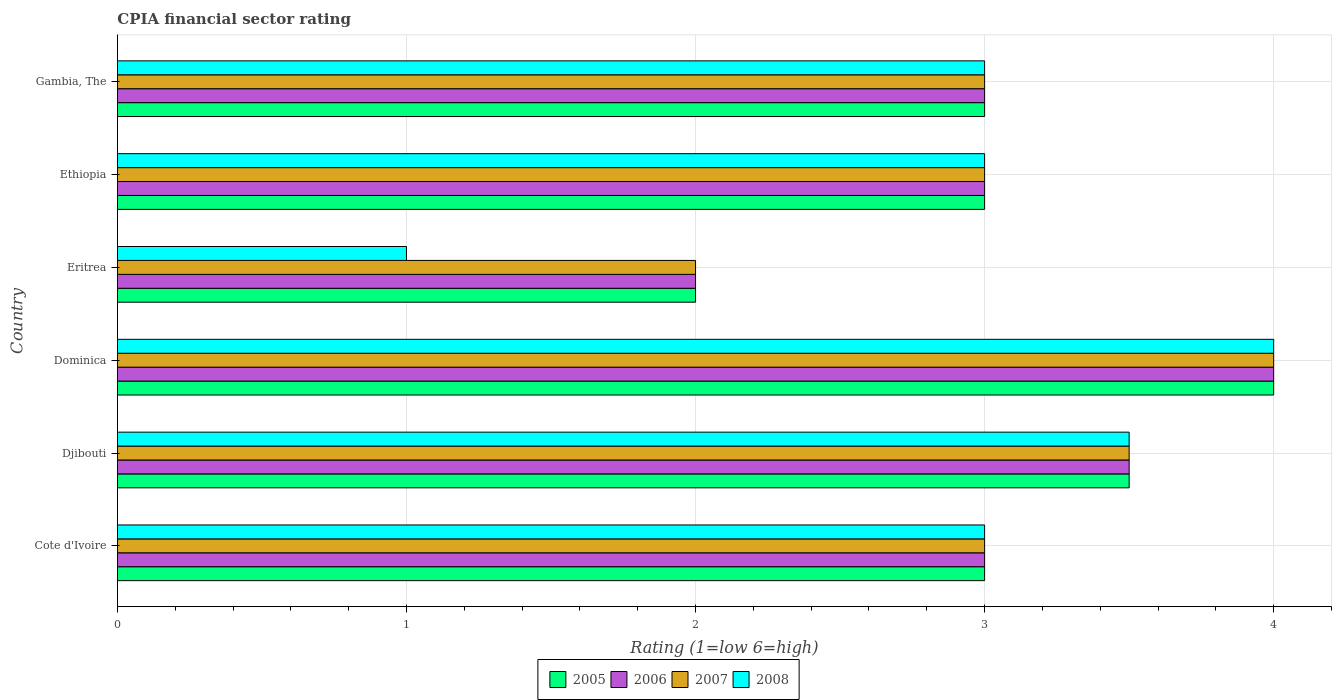Are the number of bars per tick equal to the number of legend labels?
Keep it short and to the point. Yes. Are the number of bars on each tick of the Y-axis equal?
Offer a very short reply. Yes. How many bars are there on the 6th tick from the top?
Ensure brevity in your answer.  4. What is the label of the 6th group of bars from the top?
Provide a succinct answer. Cote d'Ivoire. In which country was the CPIA rating in 2008 maximum?
Your answer should be very brief. Dominica. In which country was the CPIA rating in 2005 minimum?
Provide a short and direct response. Eritrea. What is the difference between the CPIA rating in 2006 in Cote d'Ivoire and the CPIA rating in 2008 in Djibouti?
Your response must be concise. -0.5. What is the average CPIA rating in 2006 per country?
Make the answer very short. 3.08. What is the difference between the CPIA rating in 2008 and CPIA rating in 2005 in Cote d'Ivoire?
Your response must be concise. 0. Is the CPIA rating in 2006 in Djibouti less than that in Dominica?
Make the answer very short. Yes. What is the difference between the highest and the second highest CPIA rating in 2006?
Provide a short and direct response. 0.5. Is it the case that in every country, the sum of the CPIA rating in 2008 and CPIA rating in 2007 is greater than the sum of CPIA rating in 2006 and CPIA rating in 2005?
Provide a succinct answer. No. What does the 3rd bar from the bottom in Djibouti represents?
Provide a short and direct response. 2007. How many bars are there?
Ensure brevity in your answer.  24. Are all the bars in the graph horizontal?
Keep it short and to the point. Yes. What is the difference between two consecutive major ticks on the X-axis?
Your response must be concise. 1. Are the values on the major ticks of X-axis written in scientific E-notation?
Provide a succinct answer. No. Does the graph contain any zero values?
Make the answer very short. No. Does the graph contain grids?
Offer a very short reply. Yes. Where does the legend appear in the graph?
Keep it short and to the point. Bottom center. How are the legend labels stacked?
Provide a succinct answer. Horizontal. What is the title of the graph?
Offer a very short reply. CPIA financial sector rating. Does "1999" appear as one of the legend labels in the graph?
Your answer should be compact. No. What is the label or title of the X-axis?
Your response must be concise. Rating (1=low 6=high). What is the label or title of the Y-axis?
Your answer should be compact. Country. What is the Rating (1=low 6=high) in 2005 in Djibouti?
Give a very brief answer. 3.5. What is the Rating (1=low 6=high) in 2007 in Djibouti?
Your answer should be very brief. 3.5. What is the Rating (1=low 6=high) in 2008 in Djibouti?
Give a very brief answer. 3.5. What is the Rating (1=low 6=high) of 2005 in Dominica?
Your answer should be compact. 4. What is the Rating (1=low 6=high) of 2005 in Eritrea?
Give a very brief answer. 2. What is the Rating (1=low 6=high) in 2006 in Eritrea?
Your answer should be compact. 2. What is the Rating (1=low 6=high) of 2005 in Ethiopia?
Offer a very short reply. 3. What is the Rating (1=low 6=high) of 2005 in Gambia, The?
Keep it short and to the point. 3. What is the Rating (1=low 6=high) in 2006 in Gambia, The?
Your answer should be very brief. 3. What is the Rating (1=low 6=high) of 2008 in Gambia, The?
Provide a succinct answer. 3. Across all countries, what is the maximum Rating (1=low 6=high) in 2005?
Your response must be concise. 4. Across all countries, what is the maximum Rating (1=low 6=high) of 2006?
Provide a succinct answer. 4. Across all countries, what is the minimum Rating (1=low 6=high) of 2005?
Provide a succinct answer. 2. What is the difference between the Rating (1=low 6=high) of 2005 in Cote d'Ivoire and that in Djibouti?
Give a very brief answer. -0.5. What is the difference between the Rating (1=low 6=high) in 2006 in Cote d'Ivoire and that in Djibouti?
Offer a terse response. -0.5. What is the difference between the Rating (1=low 6=high) in 2008 in Cote d'Ivoire and that in Djibouti?
Your answer should be compact. -0.5. What is the difference between the Rating (1=low 6=high) in 2005 in Cote d'Ivoire and that in Dominica?
Offer a terse response. -1. What is the difference between the Rating (1=low 6=high) in 2006 in Cote d'Ivoire and that in Dominica?
Your answer should be very brief. -1. What is the difference between the Rating (1=low 6=high) in 2006 in Cote d'Ivoire and that in Eritrea?
Your response must be concise. 1. What is the difference between the Rating (1=low 6=high) in 2006 in Cote d'Ivoire and that in Ethiopia?
Offer a terse response. 0. What is the difference between the Rating (1=low 6=high) of 2007 in Cote d'Ivoire and that in Ethiopia?
Offer a terse response. 0. What is the difference between the Rating (1=low 6=high) in 2008 in Cote d'Ivoire and that in Ethiopia?
Provide a succinct answer. 0. What is the difference between the Rating (1=low 6=high) in 2007 in Cote d'Ivoire and that in Gambia, The?
Your answer should be very brief. 0. What is the difference between the Rating (1=low 6=high) of 2006 in Djibouti and that in Dominica?
Make the answer very short. -0.5. What is the difference between the Rating (1=low 6=high) in 2008 in Djibouti and that in Dominica?
Your response must be concise. -0.5. What is the difference between the Rating (1=low 6=high) in 2006 in Djibouti and that in Eritrea?
Give a very brief answer. 1.5. What is the difference between the Rating (1=low 6=high) of 2008 in Djibouti and that in Eritrea?
Your response must be concise. 2.5. What is the difference between the Rating (1=low 6=high) in 2008 in Djibouti and that in Ethiopia?
Provide a short and direct response. 0.5. What is the difference between the Rating (1=low 6=high) of 2005 in Djibouti and that in Gambia, The?
Keep it short and to the point. 0.5. What is the difference between the Rating (1=low 6=high) of 2007 in Djibouti and that in Gambia, The?
Your response must be concise. 0.5. What is the difference between the Rating (1=low 6=high) in 2008 in Djibouti and that in Gambia, The?
Offer a terse response. 0.5. What is the difference between the Rating (1=low 6=high) of 2005 in Dominica and that in Eritrea?
Provide a succinct answer. 2. What is the difference between the Rating (1=low 6=high) of 2006 in Dominica and that in Eritrea?
Ensure brevity in your answer.  2. What is the difference between the Rating (1=low 6=high) of 2007 in Dominica and that in Eritrea?
Keep it short and to the point. 2. What is the difference between the Rating (1=low 6=high) in 2006 in Dominica and that in Ethiopia?
Keep it short and to the point. 1. What is the difference between the Rating (1=low 6=high) in 2007 in Dominica and that in Ethiopia?
Offer a terse response. 1. What is the difference between the Rating (1=low 6=high) of 2008 in Dominica and that in Ethiopia?
Your answer should be very brief. 1. What is the difference between the Rating (1=low 6=high) in 2007 in Dominica and that in Gambia, The?
Ensure brevity in your answer.  1. What is the difference between the Rating (1=low 6=high) in 2008 in Eritrea and that in Ethiopia?
Offer a terse response. -2. What is the difference between the Rating (1=low 6=high) of 2005 in Eritrea and that in Gambia, The?
Your response must be concise. -1. What is the difference between the Rating (1=low 6=high) of 2006 in Eritrea and that in Gambia, The?
Ensure brevity in your answer.  -1. What is the difference between the Rating (1=low 6=high) of 2007 in Eritrea and that in Gambia, The?
Your answer should be compact. -1. What is the difference between the Rating (1=low 6=high) in 2007 in Ethiopia and that in Gambia, The?
Your answer should be compact. 0. What is the difference between the Rating (1=low 6=high) in 2008 in Ethiopia and that in Gambia, The?
Keep it short and to the point. 0. What is the difference between the Rating (1=low 6=high) in 2005 in Cote d'Ivoire and the Rating (1=low 6=high) in 2006 in Djibouti?
Ensure brevity in your answer.  -0.5. What is the difference between the Rating (1=low 6=high) of 2005 in Cote d'Ivoire and the Rating (1=low 6=high) of 2007 in Djibouti?
Make the answer very short. -0.5. What is the difference between the Rating (1=low 6=high) of 2005 in Cote d'Ivoire and the Rating (1=low 6=high) of 2008 in Djibouti?
Ensure brevity in your answer.  -0.5. What is the difference between the Rating (1=low 6=high) of 2007 in Cote d'Ivoire and the Rating (1=low 6=high) of 2008 in Dominica?
Make the answer very short. -1. What is the difference between the Rating (1=low 6=high) of 2005 in Cote d'Ivoire and the Rating (1=low 6=high) of 2007 in Eritrea?
Provide a succinct answer. 1. What is the difference between the Rating (1=low 6=high) in 2005 in Cote d'Ivoire and the Rating (1=low 6=high) in 2008 in Eritrea?
Your answer should be compact. 2. What is the difference between the Rating (1=low 6=high) of 2006 in Cote d'Ivoire and the Rating (1=low 6=high) of 2007 in Eritrea?
Ensure brevity in your answer.  1. What is the difference between the Rating (1=low 6=high) of 2007 in Cote d'Ivoire and the Rating (1=low 6=high) of 2008 in Eritrea?
Provide a short and direct response. 2. What is the difference between the Rating (1=low 6=high) in 2005 in Cote d'Ivoire and the Rating (1=low 6=high) in 2006 in Ethiopia?
Your answer should be very brief. 0. What is the difference between the Rating (1=low 6=high) in 2005 in Cote d'Ivoire and the Rating (1=low 6=high) in 2008 in Ethiopia?
Give a very brief answer. 0. What is the difference between the Rating (1=low 6=high) of 2006 in Cote d'Ivoire and the Rating (1=low 6=high) of 2007 in Ethiopia?
Provide a short and direct response. 0. What is the difference between the Rating (1=low 6=high) of 2006 in Cote d'Ivoire and the Rating (1=low 6=high) of 2008 in Ethiopia?
Make the answer very short. 0. What is the difference between the Rating (1=low 6=high) of 2005 in Cote d'Ivoire and the Rating (1=low 6=high) of 2006 in Gambia, The?
Your answer should be compact. 0. What is the difference between the Rating (1=low 6=high) in 2005 in Cote d'Ivoire and the Rating (1=low 6=high) in 2007 in Gambia, The?
Give a very brief answer. 0. What is the difference between the Rating (1=low 6=high) of 2005 in Cote d'Ivoire and the Rating (1=low 6=high) of 2008 in Gambia, The?
Provide a succinct answer. 0. What is the difference between the Rating (1=low 6=high) in 2006 in Cote d'Ivoire and the Rating (1=low 6=high) in 2007 in Gambia, The?
Provide a succinct answer. 0. What is the difference between the Rating (1=low 6=high) of 2005 in Djibouti and the Rating (1=low 6=high) of 2006 in Dominica?
Offer a terse response. -0.5. What is the difference between the Rating (1=low 6=high) of 2005 in Djibouti and the Rating (1=low 6=high) of 2007 in Dominica?
Your answer should be very brief. -0.5. What is the difference between the Rating (1=low 6=high) in 2006 in Djibouti and the Rating (1=low 6=high) in 2007 in Dominica?
Your response must be concise. -0.5. What is the difference between the Rating (1=low 6=high) in 2007 in Djibouti and the Rating (1=low 6=high) in 2008 in Dominica?
Keep it short and to the point. -0.5. What is the difference between the Rating (1=low 6=high) of 2005 in Djibouti and the Rating (1=low 6=high) of 2006 in Eritrea?
Make the answer very short. 1.5. What is the difference between the Rating (1=low 6=high) of 2005 in Djibouti and the Rating (1=low 6=high) of 2007 in Eritrea?
Provide a short and direct response. 1.5. What is the difference between the Rating (1=low 6=high) in 2005 in Djibouti and the Rating (1=low 6=high) in 2008 in Eritrea?
Offer a very short reply. 2.5. What is the difference between the Rating (1=low 6=high) in 2006 in Djibouti and the Rating (1=low 6=high) in 2007 in Eritrea?
Ensure brevity in your answer.  1.5. What is the difference between the Rating (1=low 6=high) of 2006 in Djibouti and the Rating (1=low 6=high) of 2007 in Ethiopia?
Provide a short and direct response. 0.5. What is the difference between the Rating (1=low 6=high) of 2007 in Djibouti and the Rating (1=low 6=high) of 2008 in Ethiopia?
Offer a very short reply. 0.5. What is the difference between the Rating (1=low 6=high) of 2005 in Djibouti and the Rating (1=low 6=high) of 2007 in Gambia, The?
Your response must be concise. 0.5. What is the difference between the Rating (1=low 6=high) in 2005 in Djibouti and the Rating (1=low 6=high) in 2008 in Gambia, The?
Offer a terse response. 0.5. What is the difference between the Rating (1=low 6=high) in 2006 in Djibouti and the Rating (1=low 6=high) in 2007 in Gambia, The?
Offer a terse response. 0.5. What is the difference between the Rating (1=low 6=high) in 2005 in Dominica and the Rating (1=low 6=high) in 2006 in Eritrea?
Provide a short and direct response. 2. What is the difference between the Rating (1=low 6=high) of 2005 in Dominica and the Rating (1=low 6=high) of 2008 in Eritrea?
Offer a terse response. 3. What is the difference between the Rating (1=low 6=high) of 2006 in Dominica and the Rating (1=low 6=high) of 2007 in Eritrea?
Your answer should be very brief. 2. What is the difference between the Rating (1=low 6=high) of 2006 in Dominica and the Rating (1=low 6=high) of 2008 in Eritrea?
Provide a short and direct response. 3. What is the difference between the Rating (1=low 6=high) of 2005 in Dominica and the Rating (1=low 6=high) of 2008 in Ethiopia?
Provide a succinct answer. 1. What is the difference between the Rating (1=low 6=high) of 2006 in Dominica and the Rating (1=low 6=high) of 2007 in Ethiopia?
Offer a terse response. 1. What is the difference between the Rating (1=low 6=high) of 2006 in Dominica and the Rating (1=low 6=high) of 2008 in Ethiopia?
Your answer should be very brief. 1. What is the difference between the Rating (1=low 6=high) in 2005 in Dominica and the Rating (1=low 6=high) in 2006 in Gambia, The?
Offer a very short reply. 1. What is the difference between the Rating (1=low 6=high) of 2005 in Dominica and the Rating (1=low 6=high) of 2007 in Gambia, The?
Provide a succinct answer. 1. What is the difference between the Rating (1=low 6=high) of 2005 in Eritrea and the Rating (1=low 6=high) of 2008 in Ethiopia?
Give a very brief answer. -1. What is the difference between the Rating (1=low 6=high) in 2007 in Eritrea and the Rating (1=low 6=high) in 2008 in Ethiopia?
Give a very brief answer. -1. What is the difference between the Rating (1=low 6=high) in 2005 in Eritrea and the Rating (1=low 6=high) in 2006 in Gambia, The?
Make the answer very short. -1. What is the difference between the Rating (1=low 6=high) of 2005 in Eritrea and the Rating (1=low 6=high) of 2007 in Gambia, The?
Offer a terse response. -1. What is the difference between the Rating (1=low 6=high) of 2005 in Eritrea and the Rating (1=low 6=high) of 2008 in Gambia, The?
Keep it short and to the point. -1. What is the difference between the Rating (1=low 6=high) of 2006 in Eritrea and the Rating (1=low 6=high) of 2008 in Gambia, The?
Your response must be concise. -1. What is the difference between the Rating (1=low 6=high) in 2005 in Ethiopia and the Rating (1=low 6=high) in 2008 in Gambia, The?
Give a very brief answer. 0. What is the difference between the Rating (1=low 6=high) in 2006 in Ethiopia and the Rating (1=low 6=high) in 2007 in Gambia, The?
Make the answer very short. 0. What is the difference between the Rating (1=low 6=high) in 2006 in Ethiopia and the Rating (1=low 6=high) in 2008 in Gambia, The?
Your answer should be compact. 0. What is the difference between the Rating (1=low 6=high) of 2007 in Ethiopia and the Rating (1=low 6=high) of 2008 in Gambia, The?
Your answer should be compact. 0. What is the average Rating (1=low 6=high) of 2005 per country?
Your response must be concise. 3.08. What is the average Rating (1=low 6=high) of 2006 per country?
Your response must be concise. 3.08. What is the average Rating (1=low 6=high) of 2007 per country?
Make the answer very short. 3.08. What is the average Rating (1=low 6=high) of 2008 per country?
Give a very brief answer. 2.92. What is the difference between the Rating (1=low 6=high) of 2005 and Rating (1=low 6=high) of 2006 in Cote d'Ivoire?
Your answer should be compact. 0. What is the difference between the Rating (1=low 6=high) in 2005 and Rating (1=low 6=high) in 2007 in Cote d'Ivoire?
Your answer should be very brief. 0. What is the difference between the Rating (1=low 6=high) of 2006 and Rating (1=low 6=high) of 2007 in Cote d'Ivoire?
Your response must be concise. 0. What is the difference between the Rating (1=low 6=high) in 2006 and Rating (1=low 6=high) in 2008 in Cote d'Ivoire?
Your answer should be very brief. 0. What is the difference between the Rating (1=low 6=high) of 2007 and Rating (1=low 6=high) of 2008 in Cote d'Ivoire?
Your answer should be very brief. 0. What is the difference between the Rating (1=low 6=high) of 2005 and Rating (1=low 6=high) of 2007 in Djibouti?
Give a very brief answer. 0. What is the difference between the Rating (1=low 6=high) in 2005 and Rating (1=low 6=high) in 2008 in Djibouti?
Your answer should be compact. 0. What is the difference between the Rating (1=low 6=high) of 2005 and Rating (1=low 6=high) of 2008 in Dominica?
Ensure brevity in your answer.  0. What is the difference between the Rating (1=low 6=high) in 2006 and Rating (1=low 6=high) in 2008 in Dominica?
Make the answer very short. 0. What is the difference between the Rating (1=low 6=high) in 2007 and Rating (1=low 6=high) in 2008 in Dominica?
Your answer should be compact. 0. What is the difference between the Rating (1=low 6=high) of 2005 and Rating (1=low 6=high) of 2006 in Eritrea?
Your answer should be compact. 0. What is the difference between the Rating (1=low 6=high) in 2006 and Rating (1=low 6=high) in 2007 in Eritrea?
Provide a succinct answer. 0. What is the difference between the Rating (1=low 6=high) of 2006 and Rating (1=low 6=high) of 2007 in Ethiopia?
Provide a succinct answer. 0. What is the difference between the Rating (1=low 6=high) of 2006 and Rating (1=low 6=high) of 2008 in Ethiopia?
Your answer should be compact. 0. What is the difference between the Rating (1=low 6=high) of 2005 and Rating (1=low 6=high) of 2007 in Gambia, The?
Ensure brevity in your answer.  0. What is the difference between the Rating (1=low 6=high) in 2005 and Rating (1=low 6=high) in 2008 in Gambia, The?
Provide a short and direct response. 0. What is the difference between the Rating (1=low 6=high) of 2007 and Rating (1=low 6=high) of 2008 in Gambia, The?
Your response must be concise. 0. What is the ratio of the Rating (1=low 6=high) of 2005 in Cote d'Ivoire to that in Djibouti?
Your answer should be compact. 0.86. What is the ratio of the Rating (1=low 6=high) of 2008 in Cote d'Ivoire to that in Djibouti?
Offer a terse response. 0.86. What is the ratio of the Rating (1=low 6=high) in 2005 in Cote d'Ivoire to that in Dominica?
Ensure brevity in your answer.  0.75. What is the ratio of the Rating (1=low 6=high) in 2008 in Cote d'Ivoire to that in Dominica?
Keep it short and to the point. 0.75. What is the ratio of the Rating (1=low 6=high) in 2007 in Cote d'Ivoire to that in Eritrea?
Ensure brevity in your answer.  1.5. What is the ratio of the Rating (1=low 6=high) of 2008 in Cote d'Ivoire to that in Eritrea?
Your response must be concise. 3. What is the ratio of the Rating (1=low 6=high) of 2006 in Cote d'Ivoire to that in Ethiopia?
Give a very brief answer. 1. What is the ratio of the Rating (1=low 6=high) in 2008 in Cote d'Ivoire to that in Ethiopia?
Your answer should be compact. 1. What is the ratio of the Rating (1=low 6=high) of 2007 in Cote d'Ivoire to that in Gambia, The?
Your answer should be very brief. 1. What is the ratio of the Rating (1=low 6=high) in 2008 in Cote d'Ivoire to that in Gambia, The?
Your answer should be compact. 1. What is the ratio of the Rating (1=low 6=high) of 2006 in Djibouti to that in Dominica?
Keep it short and to the point. 0.88. What is the ratio of the Rating (1=low 6=high) of 2006 in Djibouti to that in Eritrea?
Keep it short and to the point. 1.75. What is the ratio of the Rating (1=low 6=high) in 2007 in Djibouti to that in Eritrea?
Provide a short and direct response. 1.75. What is the ratio of the Rating (1=low 6=high) in 2005 in Djibouti to that in Ethiopia?
Ensure brevity in your answer.  1.17. What is the ratio of the Rating (1=low 6=high) of 2006 in Djibouti to that in Ethiopia?
Ensure brevity in your answer.  1.17. What is the ratio of the Rating (1=low 6=high) of 2005 in Djibouti to that in Gambia, The?
Offer a terse response. 1.17. What is the ratio of the Rating (1=low 6=high) of 2008 in Djibouti to that in Gambia, The?
Your response must be concise. 1.17. What is the ratio of the Rating (1=low 6=high) in 2006 in Dominica to that in Eritrea?
Your answer should be compact. 2. What is the ratio of the Rating (1=low 6=high) of 2008 in Dominica to that in Eritrea?
Provide a short and direct response. 4. What is the ratio of the Rating (1=low 6=high) of 2005 in Dominica to that in Ethiopia?
Provide a succinct answer. 1.33. What is the ratio of the Rating (1=low 6=high) in 2007 in Dominica to that in Ethiopia?
Offer a very short reply. 1.33. What is the ratio of the Rating (1=low 6=high) in 2006 in Dominica to that in Gambia, The?
Make the answer very short. 1.33. What is the ratio of the Rating (1=low 6=high) of 2006 in Eritrea to that in Ethiopia?
Provide a succinct answer. 0.67. What is the ratio of the Rating (1=low 6=high) in 2007 in Eritrea to that in Ethiopia?
Offer a terse response. 0.67. What is the ratio of the Rating (1=low 6=high) of 2008 in Eritrea to that in Ethiopia?
Provide a succinct answer. 0.33. What is the ratio of the Rating (1=low 6=high) in 2005 in Eritrea to that in Gambia, The?
Offer a very short reply. 0.67. What is the ratio of the Rating (1=low 6=high) in 2006 in Eritrea to that in Gambia, The?
Keep it short and to the point. 0.67. What is the ratio of the Rating (1=low 6=high) in 2008 in Eritrea to that in Gambia, The?
Offer a terse response. 0.33. What is the ratio of the Rating (1=low 6=high) in 2005 in Ethiopia to that in Gambia, The?
Offer a very short reply. 1. What is the ratio of the Rating (1=low 6=high) in 2006 in Ethiopia to that in Gambia, The?
Keep it short and to the point. 1. What is the ratio of the Rating (1=low 6=high) in 2007 in Ethiopia to that in Gambia, The?
Offer a very short reply. 1. What is the difference between the highest and the second highest Rating (1=low 6=high) of 2006?
Offer a very short reply. 0.5. What is the difference between the highest and the second highest Rating (1=low 6=high) of 2007?
Provide a short and direct response. 0.5. What is the difference between the highest and the second highest Rating (1=low 6=high) of 2008?
Give a very brief answer. 0.5. What is the difference between the highest and the lowest Rating (1=low 6=high) in 2007?
Ensure brevity in your answer.  2. 